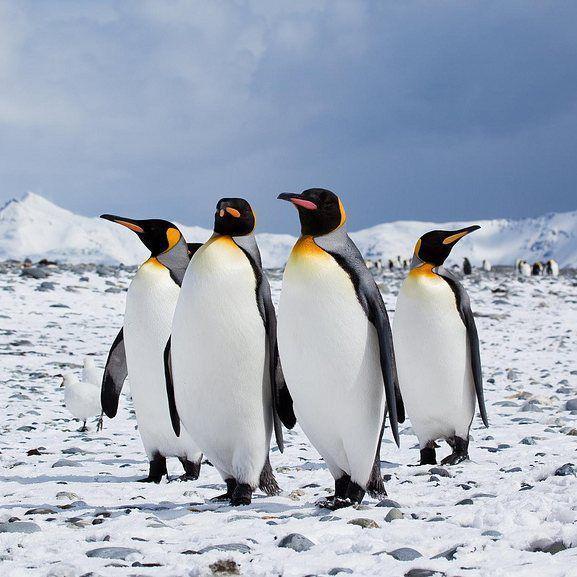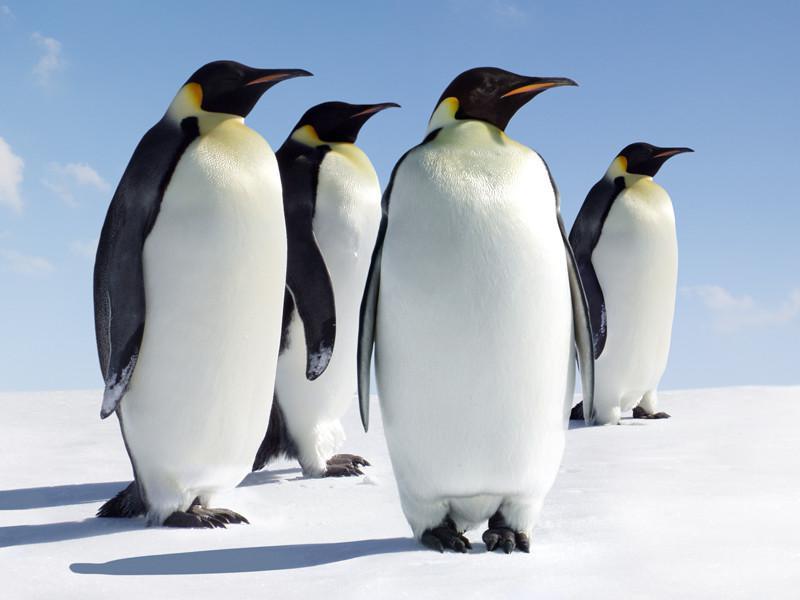The first image is the image on the left, the second image is the image on the right. Given the left and right images, does the statement "In one image the penguins are in the water" hold true? Answer yes or no. No. The first image is the image on the left, the second image is the image on the right. For the images displayed, is the sentence "The left image has no more than 4 penguins" factually correct? Answer yes or no. Yes. 